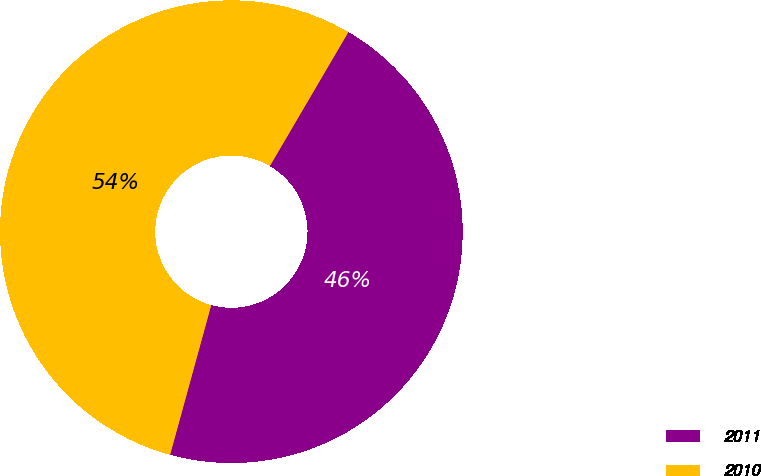Convert chart. <chart><loc_0><loc_0><loc_500><loc_500><pie_chart><fcel>2011<fcel>2010<nl><fcel>45.83%<fcel>54.17%<nl></chart> 